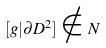Convert formula to latex. <formula><loc_0><loc_0><loc_500><loc_500>[ g | \partial D ^ { 2 } ] \notin N</formula> 